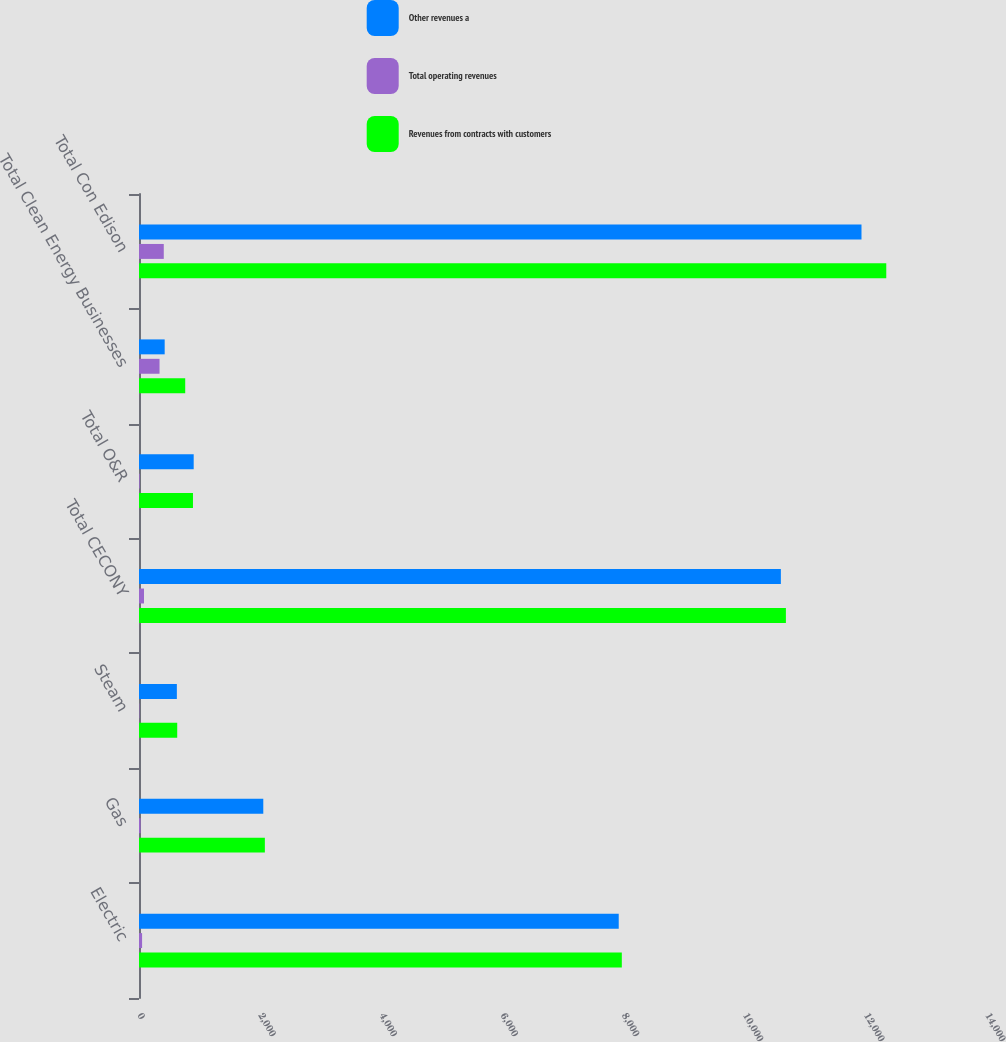Convert chart to OTSL. <chart><loc_0><loc_0><loc_500><loc_500><stacked_bar_chart><ecel><fcel>Electric<fcel>Gas<fcel>Steam<fcel>Total CECONY<fcel>Total O&R<fcel>Total Clean Energy Businesses<fcel>Total Con Edison<nl><fcel>Other revenues a<fcel>7920<fcel>2052<fcel>625<fcel>10597<fcel>903<fcel>424<fcel>11928<nl><fcel>Total operating revenues<fcel>51<fcel>26<fcel>6<fcel>83<fcel>12<fcel>339<fcel>409<nl><fcel>Revenues from contracts with customers<fcel>7971<fcel>2078<fcel>631<fcel>10680<fcel>891<fcel>763<fcel>12337<nl></chart> 